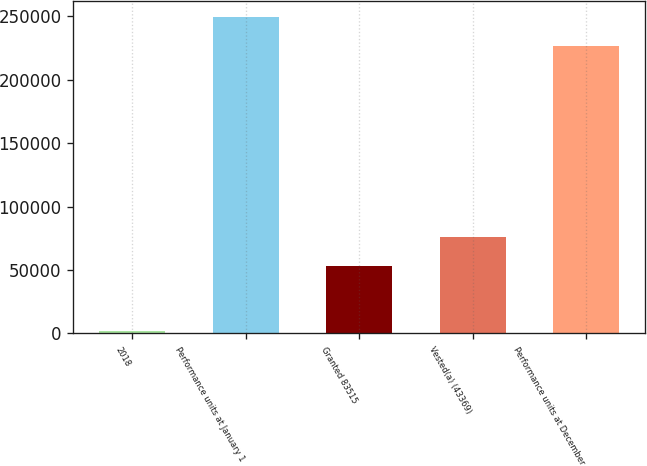<chart> <loc_0><loc_0><loc_500><loc_500><bar_chart><fcel>2018<fcel>Performance units at January 1<fcel>Granted 83515<fcel>Vested(a) (43369)<fcel>Performance units at December<nl><fcel>2017<fcel>249565<fcel>53070<fcel>76077.1<fcel>226558<nl></chart> 